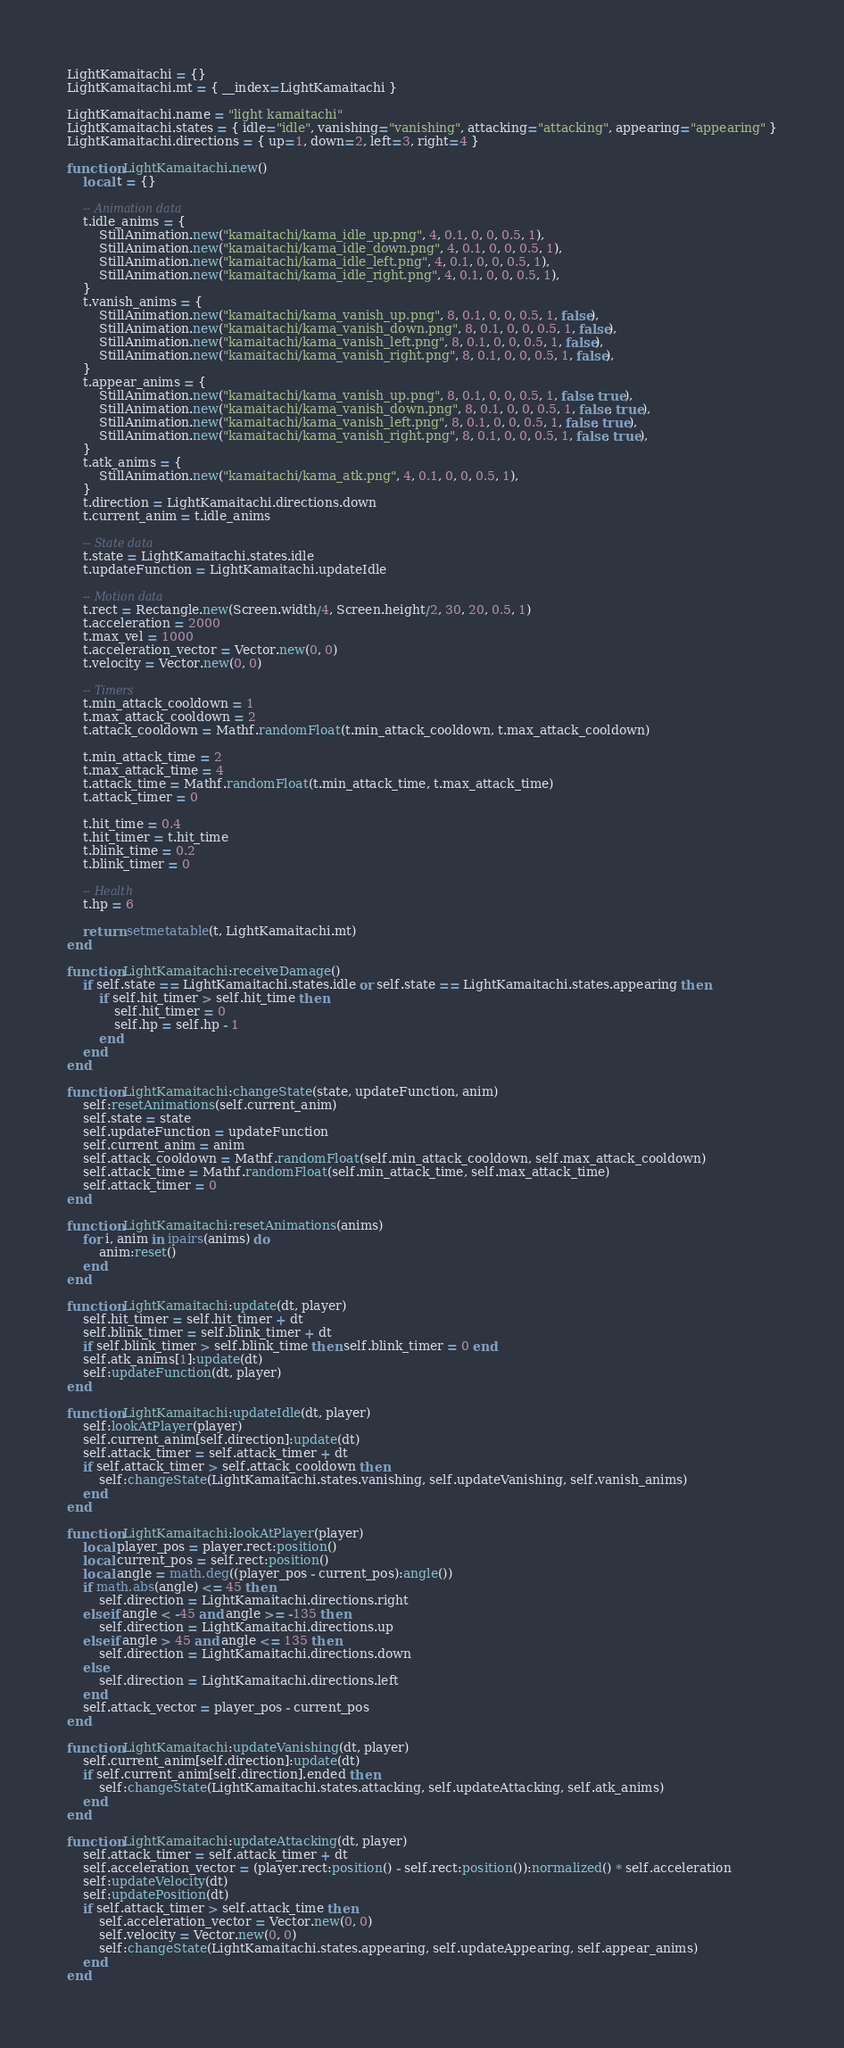Convert code to text. <code><loc_0><loc_0><loc_500><loc_500><_Lua_>LightKamaitachi = {}
LightKamaitachi.mt = { __index=LightKamaitachi }

LightKamaitachi.name = "light kamaitachi"
LightKamaitachi.states = { idle="idle", vanishing="vanishing", attacking="attacking", appearing="appearing" }
LightKamaitachi.directions = { up=1, down=2, left=3, right=4 }

function LightKamaitachi.new()
    local t = {}

    -- Animation data
    t.idle_anims = {
        StillAnimation.new("kamaitachi/kama_idle_up.png", 4, 0.1, 0, 0, 0.5, 1),
        StillAnimation.new("kamaitachi/kama_idle_down.png", 4, 0.1, 0, 0, 0.5, 1),
        StillAnimation.new("kamaitachi/kama_idle_left.png", 4, 0.1, 0, 0, 0.5, 1),
        StillAnimation.new("kamaitachi/kama_idle_right.png", 4, 0.1, 0, 0, 0.5, 1),
    }
    t.vanish_anims = {
        StillAnimation.new("kamaitachi/kama_vanish_up.png", 8, 0.1, 0, 0, 0.5, 1, false),
        StillAnimation.new("kamaitachi/kama_vanish_down.png", 8, 0.1, 0, 0, 0.5, 1, false),
        StillAnimation.new("kamaitachi/kama_vanish_left.png", 8, 0.1, 0, 0, 0.5, 1, false),
        StillAnimation.new("kamaitachi/kama_vanish_right.png", 8, 0.1, 0, 0, 0.5, 1, false),
    }
    t.appear_anims = {
        StillAnimation.new("kamaitachi/kama_vanish_up.png", 8, 0.1, 0, 0, 0.5, 1, false, true),
        StillAnimation.new("kamaitachi/kama_vanish_down.png", 8, 0.1, 0, 0, 0.5, 1, false, true),
        StillAnimation.new("kamaitachi/kama_vanish_left.png", 8, 0.1, 0, 0, 0.5, 1, false, true),
        StillAnimation.new("kamaitachi/kama_vanish_right.png", 8, 0.1, 0, 0, 0.5, 1, false, true),
    }
    t.atk_anims = {
        StillAnimation.new("kamaitachi/kama_atk.png", 4, 0.1, 0, 0, 0.5, 1),
    }
    t.direction = LightKamaitachi.directions.down
    t.current_anim = t.idle_anims

    -- State data
    t.state = LightKamaitachi.states.idle
    t.updateFunction = LightKamaitachi.updateIdle

    -- Motion data
    t.rect = Rectangle.new(Screen.width/4, Screen.height/2, 30, 20, 0.5, 1)
    t.acceleration = 2000
    t.max_vel = 1000
    t.acceleration_vector = Vector.new(0, 0)
    t.velocity = Vector.new(0, 0)

    -- Timers
    t.min_attack_cooldown = 1
    t.max_attack_cooldown = 2
    t.attack_cooldown = Mathf.randomFloat(t.min_attack_cooldown, t.max_attack_cooldown)

    t.min_attack_time = 2
    t.max_attack_time = 4
    t.attack_time = Mathf.randomFloat(t.min_attack_time, t.max_attack_time)
    t.attack_timer = 0

    t.hit_time = 0.4
    t.hit_timer = t.hit_time
    t.blink_time = 0.2
    t.blink_timer = 0

    -- Health
    t.hp = 6

    return setmetatable(t, LightKamaitachi.mt)
end

function LightKamaitachi:receiveDamage()
    if self.state == LightKamaitachi.states.idle or self.state == LightKamaitachi.states.appearing then
        if self.hit_timer > self.hit_time then
            self.hit_timer = 0
            self.hp = self.hp - 1
        end
    end
end

function LightKamaitachi:changeState(state, updateFunction, anim)
    self:resetAnimations(self.current_anim)
    self.state = state
    self.updateFunction = updateFunction
    self.current_anim = anim
    self.attack_cooldown = Mathf.randomFloat(self.min_attack_cooldown, self.max_attack_cooldown)
    self.attack_time = Mathf.randomFloat(self.min_attack_time, self.max_attack_time)
    self.attack_timer = 0
end

function LightKamaitachi:resetAnimations(anims)
    for i, anim in ipairs(anims) do
        anim:reset()
    end
end

function LightKamaitachi:update(dt, player)
    self.hit_timer = self.hit_timer + dt
    self.blink_timer = self.blink_timer + dt
    if self.blink_timer > self.blink_time then self.blink_timer = 0 end
    self.atk_anims[1]:update(dt)
    self:updateFunction(dt, player)
end

function LightKamaitachi:updateIdle(dt, player)
    self:lookAtPlayer(player)
    self.current_anim[self.direction]:update(dt)
    self.attack_timer = self.attack_timer + dt
    if self.attack_timer > self.attack_cooldown then
        self:changeState(LightKamaitachi.states.vanishing, self.updateVanishing, self.vanish_anims)
    end
end

function LightKamaitachi:lookAtPlayer(player)
    local player_pos = player.rect:position()
    local current_pos = self.rect:position()
    local angle = math.deg((player_pos - current_pos):angle())
    if math.abs(angle) <= 45 then
        self.direction = LightKamaitachi.directions.right
    elseif angle < -45 and angle >= -135 then
        self.direction = LightKamaitachi.directions.up
    elseif angle > 45 and angle <= 135 then
        self.direction = LightKamaitachi.directions.down
    else
        self.direction = LightKamaitachi.directions.left
    end
    self.attack_vector = player_pos - current_pos
end

function LightKamaitachi:updateVanishing(dt, player)
    self.current_anim[self.direction]:update(dt)
    if self.current_anim[self.direction].ended then
        self:changeState(LightKamaitachi.states.attacking, self.updateAttacking, self.atk_anims)
    end
end

function LightKamaitachi:updateAttacking(dt, player)
    self.attack_timer = self.attack_timer + dt
    self.acceleration_vector = (player.rect:position() - self.rect:position()):normalized() * self.acceleration
    self:updateVelocity(dt)
    self:updatePosition(dt)
    if self.attack_timer > self.attack_time then
        self.acceleration_vector = Vector.new(0, 0)
        self.velocity = Vector.new(0, 0)
        self:changeState(LightKamaitachi.states.appearing, self.updateAppearing, self.appear_anims)
    end
end
</code> 